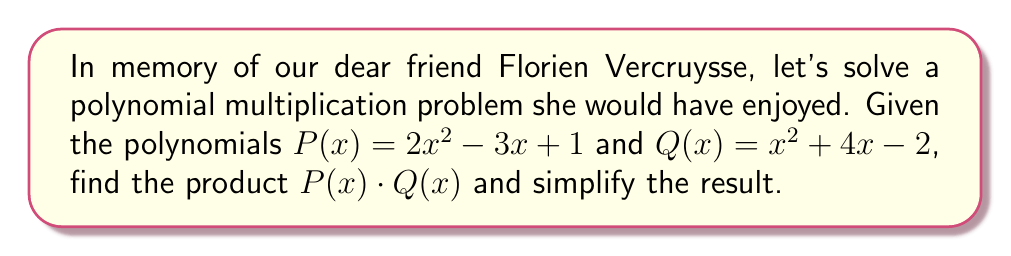Teach me how to tackle this problem. Let's approach this step-by-step:

1) To multiply these polynomials, we need to multiply each term of $P(x)$ by each term of $Q(x)$ and then combine like terms.

2) Let's start with $2x^2$ from $P(x)$:
   $2x^2(x^2) = 2x^4$
   $2x^2(4x) = 8x^3$
   $2x^2(-2) = -4x^2$

3) Now, let's multiply $-3x$ from $P(x)$:
   $-3x(x^2) = -3x^3$
   $-3x(4x) = -12x^2$
   $-3x(-2) = 6x$

4) Finally, let's multiply the constant term 1 from $P(x)$:
   $1(x^2) = x^2$
   $1(4x) = 4x$
   $1(-2) = -2$

5) Now, we combine all these terms:
   $2x^4 + 8x^3 - 4x^2 - 3x^3 - 12x^2 + 6x + x^2 + 4x - 2$

6) Let's group like terms:
   $2x^4 + (8x^3 - 3x^3) + (-4x^2 - 12x^2 + x^2) + (6x + 4x) - 2$

7) Simplify:
   $2x^4 + 5x^3 - 15x^2 + 10x - 2$

This is our final, simplified result.
Answer: $2x^4 + 5x^3 - 15x^2 + 10x - 2$ 